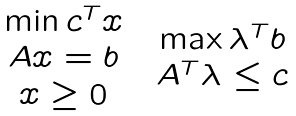<formula> <loc_0><loc_0><loc_500><loc_500>\begin{array} [ c ] { c c } & \\ \begin{array} [ c ] { c } \min c ^ { T } x \\ A x = b \\ x \geq 0 \end{array} & \begin{array} [ c ] { c } \max \lambda ^ { T } b \\ A ^ { T } \lambda \leq c \end{array} \end{array}</formula> 